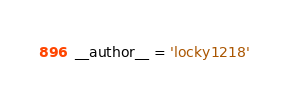Convert code to text. <code><loc_0><loc_0><loc_500><loc_500><_Python_>__author__ = 'locky1218'
</code> 